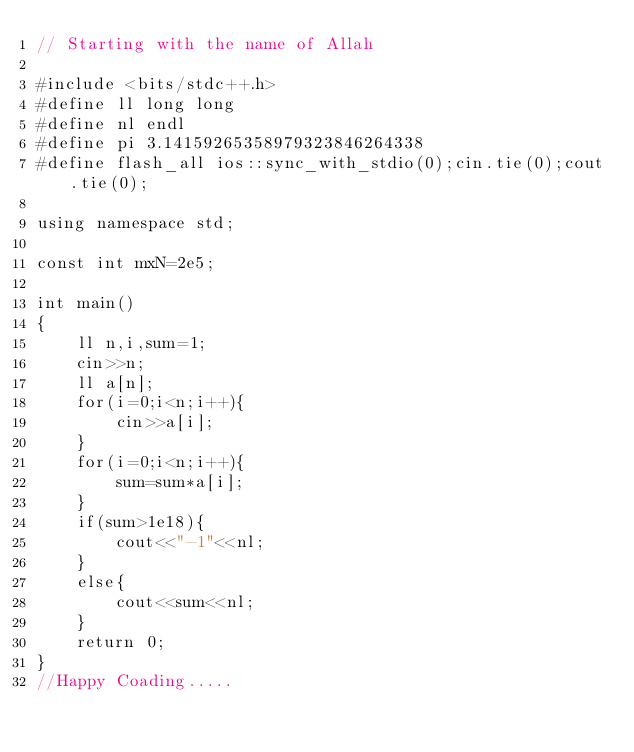<code> <loc_0><loc_0><loc_500><loc_500><_C++_>// Starting with the name of Allah

#include <bits/stdc++.h>
#define ll long long
#define nl endl
#define pi 3.14159265358979323846264338
#define flash_all ios::sync_with_stdio(0);cin.tie(0);cout.tie(0);

using namespace std;

const int mxN=2e5;

int main()
{
	ll n,i,sum=1;
	cin>>n;
	ll a[n];
	for(i=0;i<n;i++){
		cin>>a[i];
	}
	for(i=0;i<n;i++){
		sum=sum*a[i];
	}
	if(sum>1e18){
		cout<<"-1"<<nl;
	}
	else{
		cout<<sum<<nl;
	}
	return 0;
}
//Happy Coading.....
</code> 